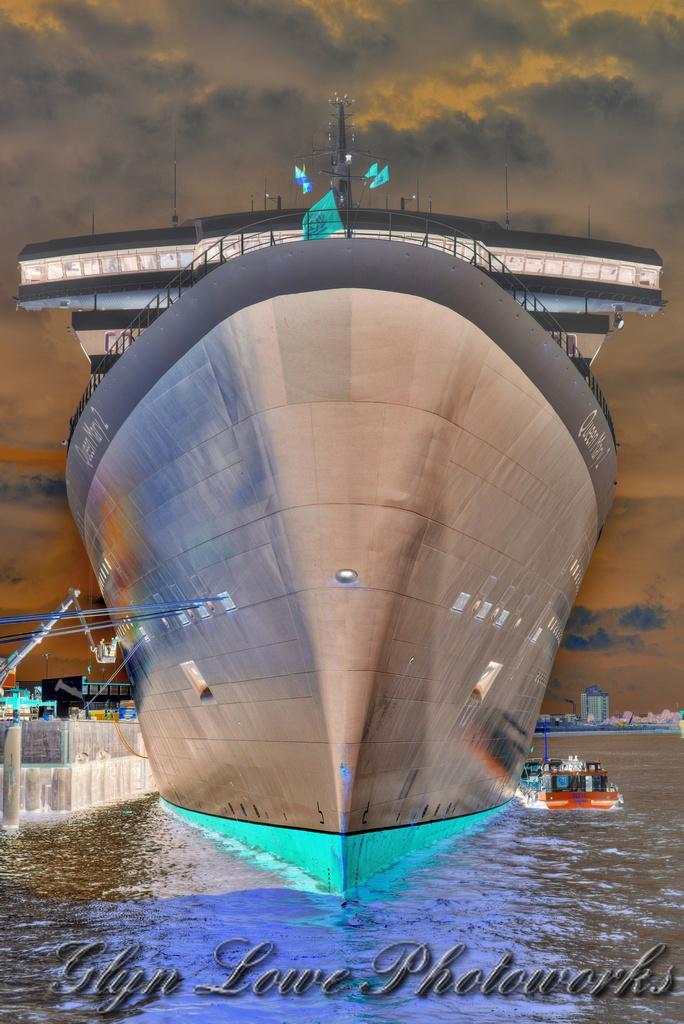Can you describe this image briefly? In this image in front there are ships in the water. In the background of the image there are buildings and sky. There is some text written at the bottom of the image. 